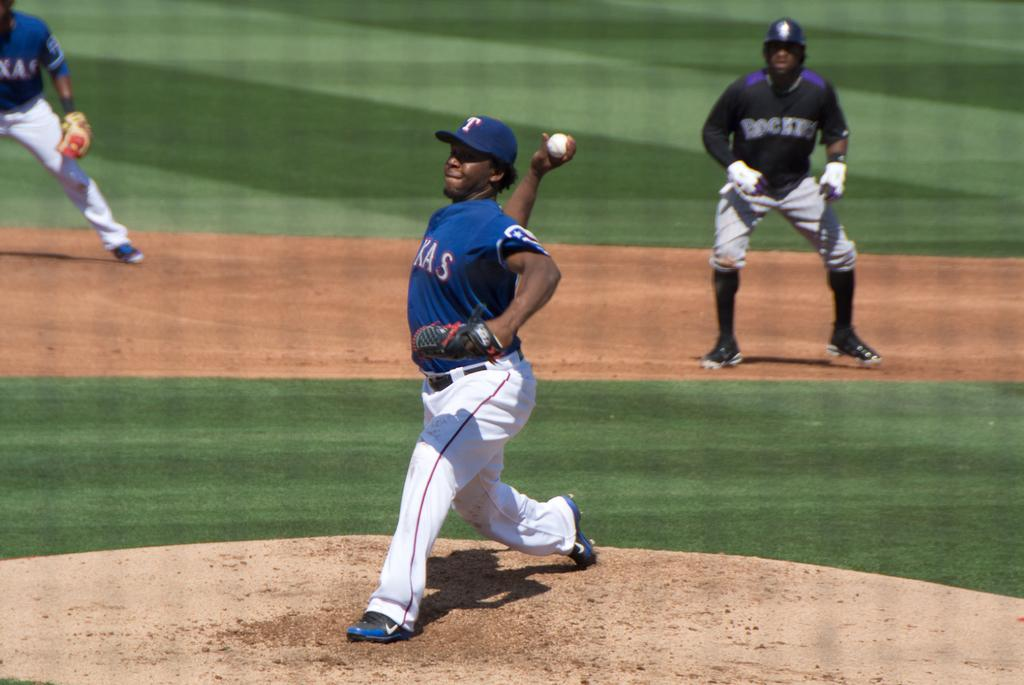<image>
Summarize the visual content of the image. Men are playing baseball and one man has the word ROCKETS on his shirt. 